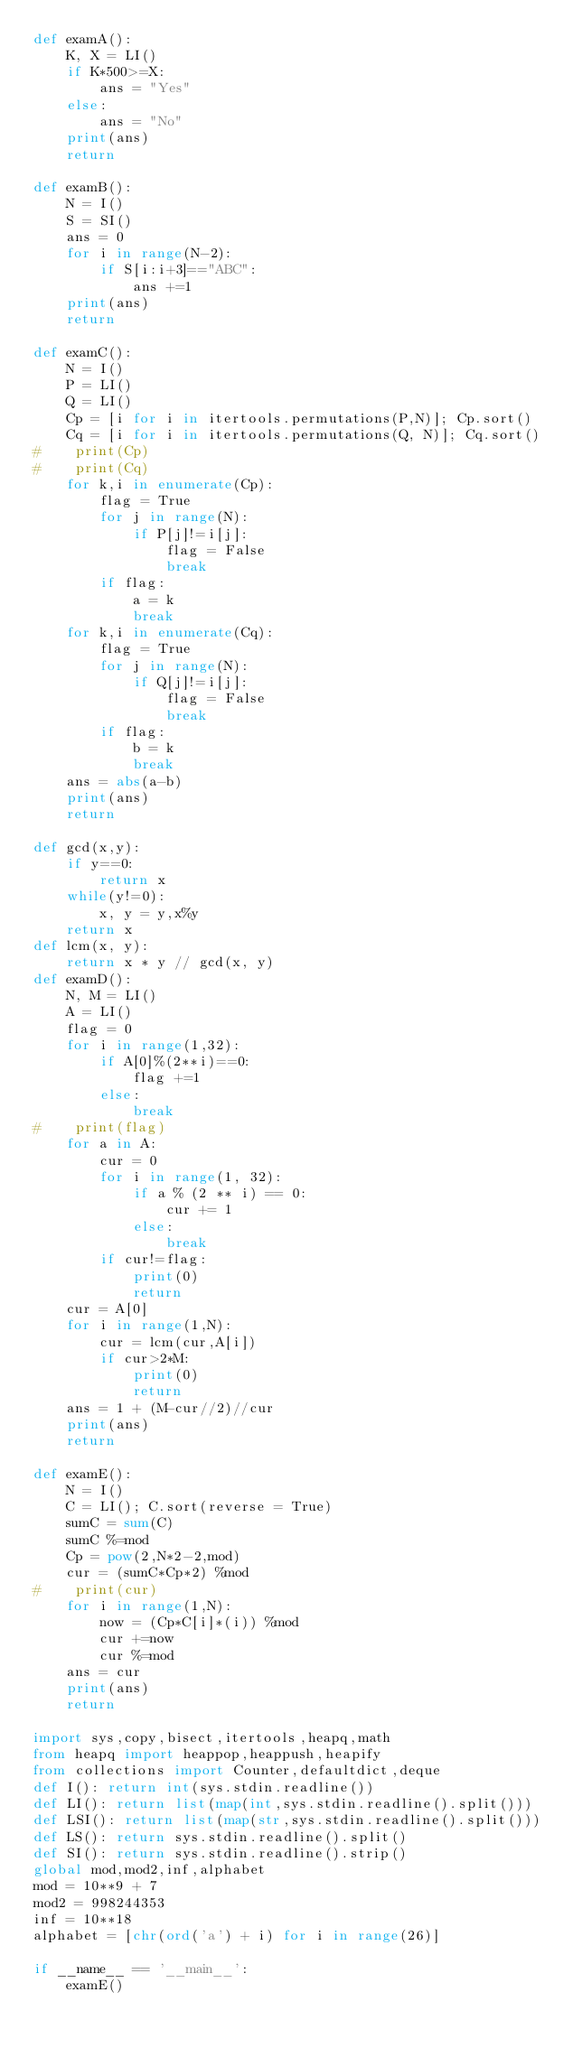<code> <loc_0><loc_0><loc_500><loc_500><_Python_>def examA():
    K, X = LI()
    if K*500>=X:
        ans = "Yes"
    else:
        ans = "No"
    print(ans)
    return

def examB():
    N = I()
    S = SI()
    ans = 0
    for i in range(N-2):
        if S[i:i+3]=="ABC":
            ans +=1
    print(ans)
    return

def examC():
    N = I()
    P = LI()
    Q = LI()
    Cp = [i for i in itertools.permutations(P,N)]; Cp.sort()
    Cq = [i for i in itertools.permutations(Q, N)]; Cq.sort()
#    print(Cp)
#    print(Cq)
    for k,i in enumerate(Cp):
        flag = True
        for j in range(N):
            if P[j]!=i[j]:
                flag = False
                break
        if flag:
            a = k
            break
    for k,i in enumerate(Cq):
        flag = True
        for j in range(N):
            if Q[j]!=i[j]:
                flag = False
                break
        if flag:
            b = k
            break
    ans = abs(a-b)
    print(ans)
    return

def gcd(x,y):
    if y==0:
        return x
    while(y!=0):
        x, y = y,x%y
    return x
def lcm(x, y):
    return x * y // gcd(x, y)
def examD():
    N, M = LI()
    A = LI()
    flag = 0
    for i in range(1,32):
        if A[0]%(2**i)==0:
            flag +=1
        else:
            break
#    print(flag)
    for a in A:
        cur = 0
        for i in range(1, 32):
            if a % (2 ** i) == 0:
                cur += 1
            else:
                break
        if cur!=flag:
            print(0)
            return
    cur = A[0]
    for i in range(1,N):
        cur = lcm(cur,A[i])
        if cur>2*M:
            print(0)
            return
    ans = 1 + (M-cur//2)//cur
    print(ans)
    return

def examE():
    N = I()
    C = LI(); C.sort(reverse = True)
    sumC = sum(C)
    sumC %=mod
    Cp = pow(2,N*2-2,mod)
    cur = (sumC*Cp*2) %mod
#    print(cur)
    for i in range(1,N):
        now = (Cp*C[i]*(i)) %mod
        cur +=now
        cur %=mod
    ans = cur
    print(ans)
    return

import sys,copy,bisect,itertools,heapq,math
from heapq import heappop,heappush,heapify
from collections import Counter,defaultdict,deque
def I(): return int(sys.stdin.readline())
def LI(): return list(map(int,sys.stdin.readline().split()))
def LSI(): return list(map(str,sys.stdin.readline().split()))
def LS(): return sys.stdin.readline().split()
def SI(): return sys.stdin.readline().strip()
global mod,mod2,inf,alphabet
mod = 10**9 + 7
mod2 = 998244353
inf = 10**18
alphabet = [chr(ord('a') + i) for i in range(26)]

if __name__ == '__main__':
    examE()
</code> 